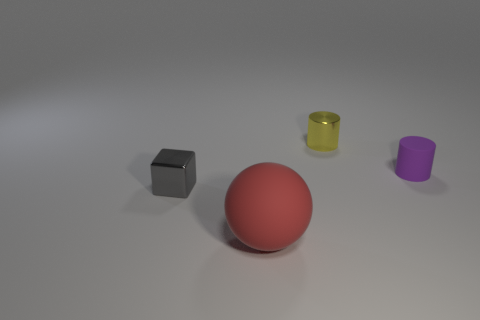Subtract all green balls. Subtract all green cylinders. How many balls are left? 1 Add 2 tiny metallic cylinders. How many objects exist? 6 Subtract all spheres. How many objects are left? 3 Subtract 0 cyan cubes. How many objects are left? 4 Subtract all tiny shiny blocks. Subtract all tiny shiny cylinders. How many objects are left? 2 Add 2 purple matte things. How many purple matte things are left? 3 Add 1 purple matte objects. How many purple matte objects exist? 2 